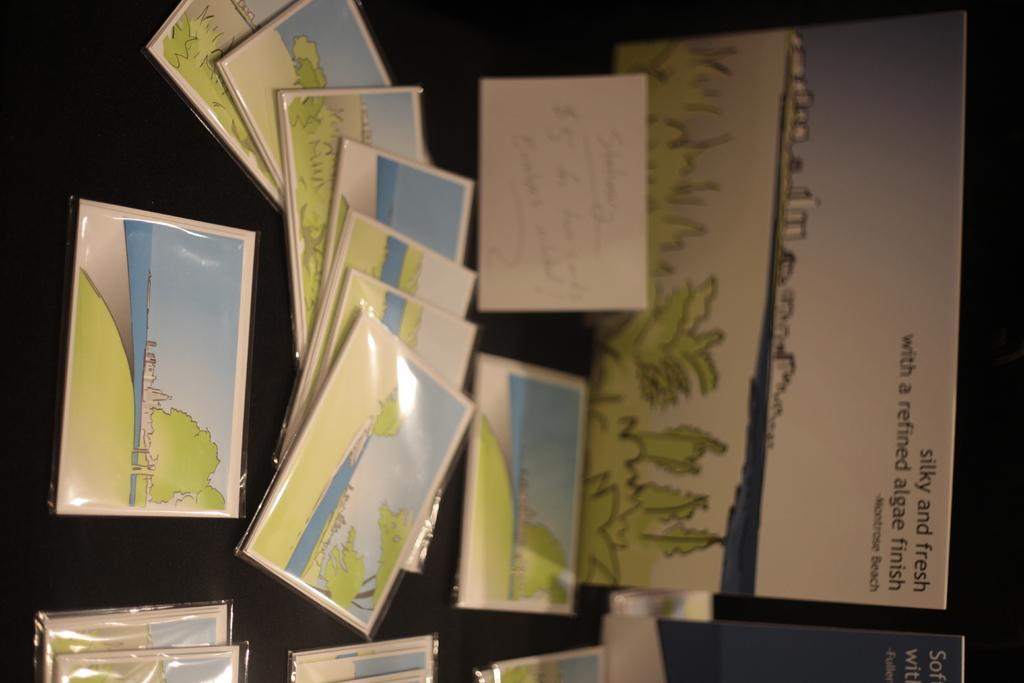<image>
Offer a succinct explanation of the picture presented. A sign that says silky and fresh sits near several wrapped cards showing a landscape. 